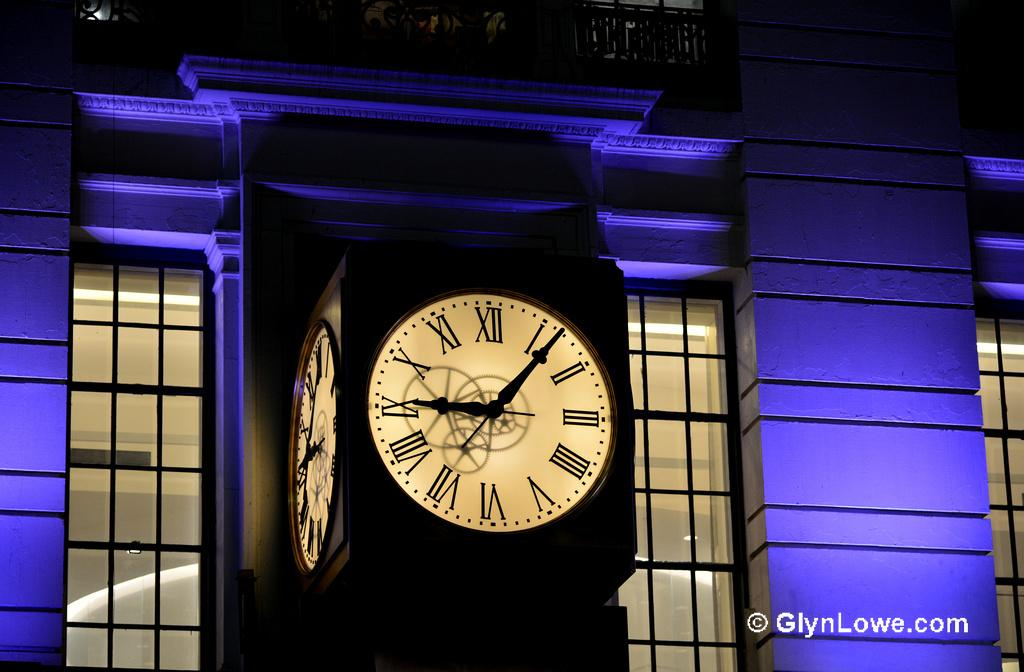<image>
Give a short and clear explanation of the subsequent image. A clock outside a building lit up with blue light with a watermark for GlynLowe.com on it 